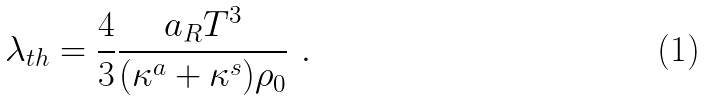Convert formula to latex. <formula><loc_0><loc_0><loc_500><loc_500>\lambda _ { t h } = \frac { 4 } { 3 } \frac { a _ { R } T ^ { 3 } } { ( \kappa ^ { a } + \kappa ^ { s } ) \rho _ { 0 } } \ .</formula> 